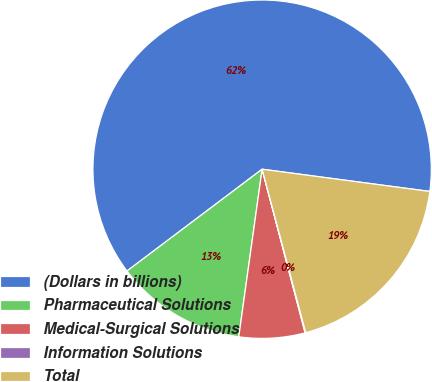Convert chart to OTSL. <chart><loc_0><loc_0><loc_500><loc_500><pie_chart><fcel>(Dollars in billions)<fcel>Pharmaceutical Solutions<fcel>Medical-Surgical Solutions<fcel>Information Solutions<fcel>Total<nl><fcel>62.37%<fcel>12.52%<fcel>6.29%<fcel>0.06%<fcel>18.75%<nl></chart> 